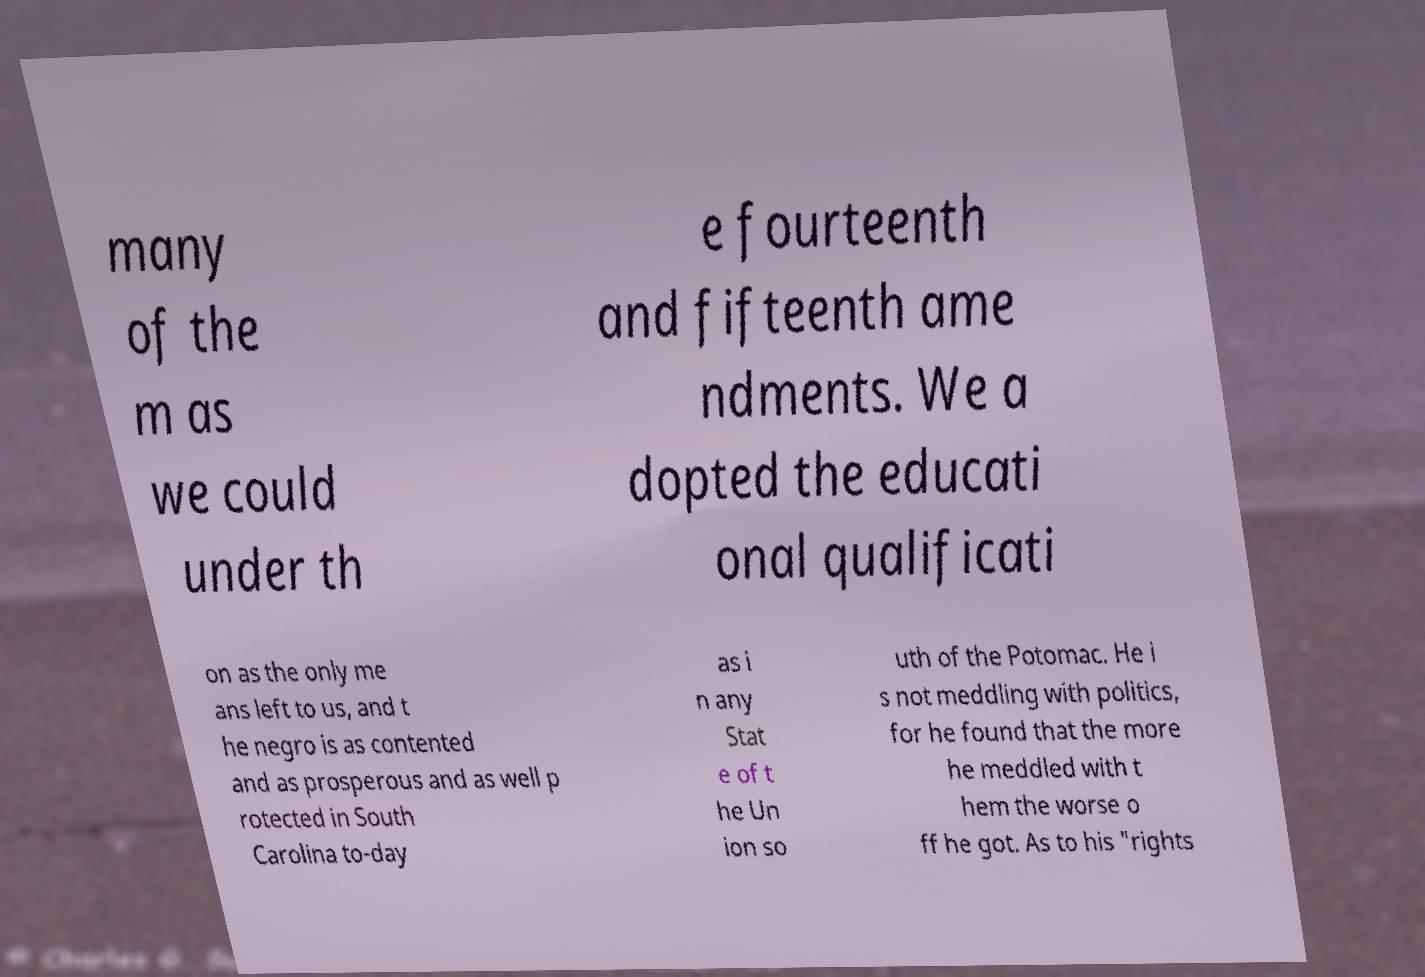Can you read and provide the text displayed in the image?This photo seems to have some interesting text. Can you extract and type it out for me? many of the m as we could under th e fourteenth and fifteenth ame ndments. We a dopted the educati onal qualificati on as the only me ans left to us, and t he negro is as contented and as prosperous and as well p rotected in South Carolina to-day as i n any Stat e of t he Un ion so uth of the Potomac. He i s not meddling with politics, for he found that the more he meddled with t hem the worse o ff he got. As to his "rights 